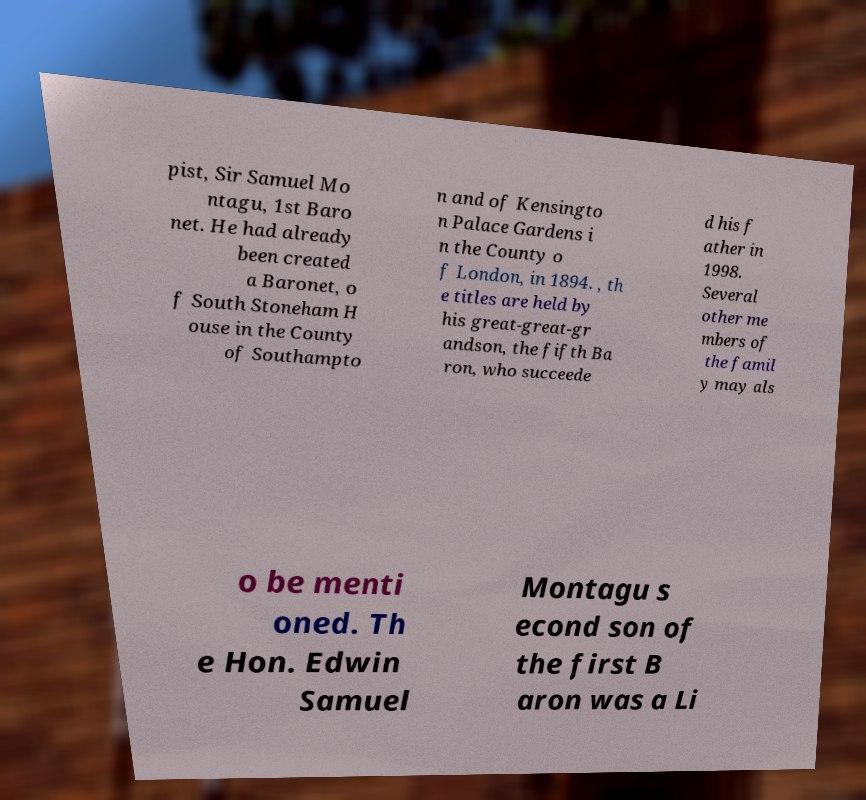Please read and relay the text visible in this image. What does it say? pist, Sir Samuel Mo ntagu, 1st Baro net. He had already been created a Baronet, o f South Stoneham H ouse in the County of Southampto n and of Kensingto n Palace Gardens i n the County o f London, in 1894. , th e titles are held by his great-great-gr andson, the fifth Ba ron, who succeede d his f ather in 1998. Several other me mbers of the famil y may als o be menti oned. Th e Hon. Edwin Samuel Montagu s econd son of the first B aron was a Li 